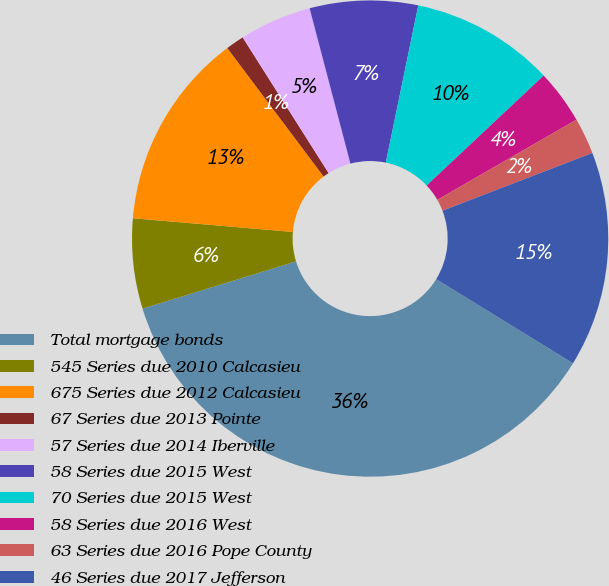<chart> <loc_0><loc_0><loc_500><loc_500><pie_chart><fcel>Total mortgage bonds<fcel>545 Series due 2010 Calcasieu<fcel>675 Series due 2012 Calcasieu<fcel>67 Series due 2013 Pointe<fcel>57 Series due 2014 Iberville<fcel>58 Series due 2015 West<fcel>70 Series due 2015 West<fcel>58 Series due 2016 West<fcel>63 Series due 2016 Pope County<fcel>46 Series due 2017 Jefferson<nl><fcel>36.48%<fcel>6.11%<fcel>13.4%<fcel>1.25%<fcel>4.9%<fcel>7.33%<fcel>9.76%<fcel>3.68%<fcel>2.47%<fcel>14.62%<nl></chart> 